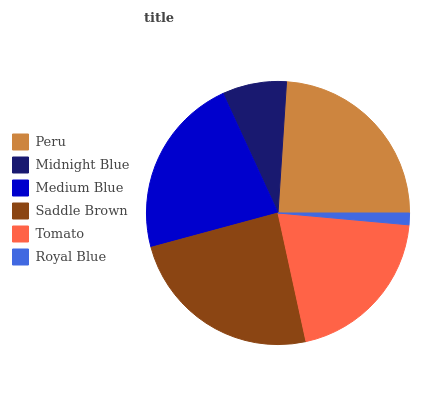Is Royal Blue the minimum?
Answer yes or no. Yes. Is Saddle Brown the maximum?
Answer yes or no. Yes. Is Midnight Blue the minimum?
Answer yes or no. No. Is Midnight Blue the maximum?
Answer yes or no. No. Is Peru greater than Midnight Blue?
Answer yes or no. Yes. Is Midnight Blue less than Peru?
Answer yes or no. Yes. Is Midnight Blue greater than Peru?
Answer yes or no. No. Is Peru less than Midnight Blue?
Answer yes or no. No. Is Medium Blue the high median?
Answer yes or no. Yes. Is Tomato the low median?
Answer yes or no. Yes. Is Midnight Blue the high median?
Answer yes or no. No. Is Midnight Blue the low median?
Answer yes or no. No. 